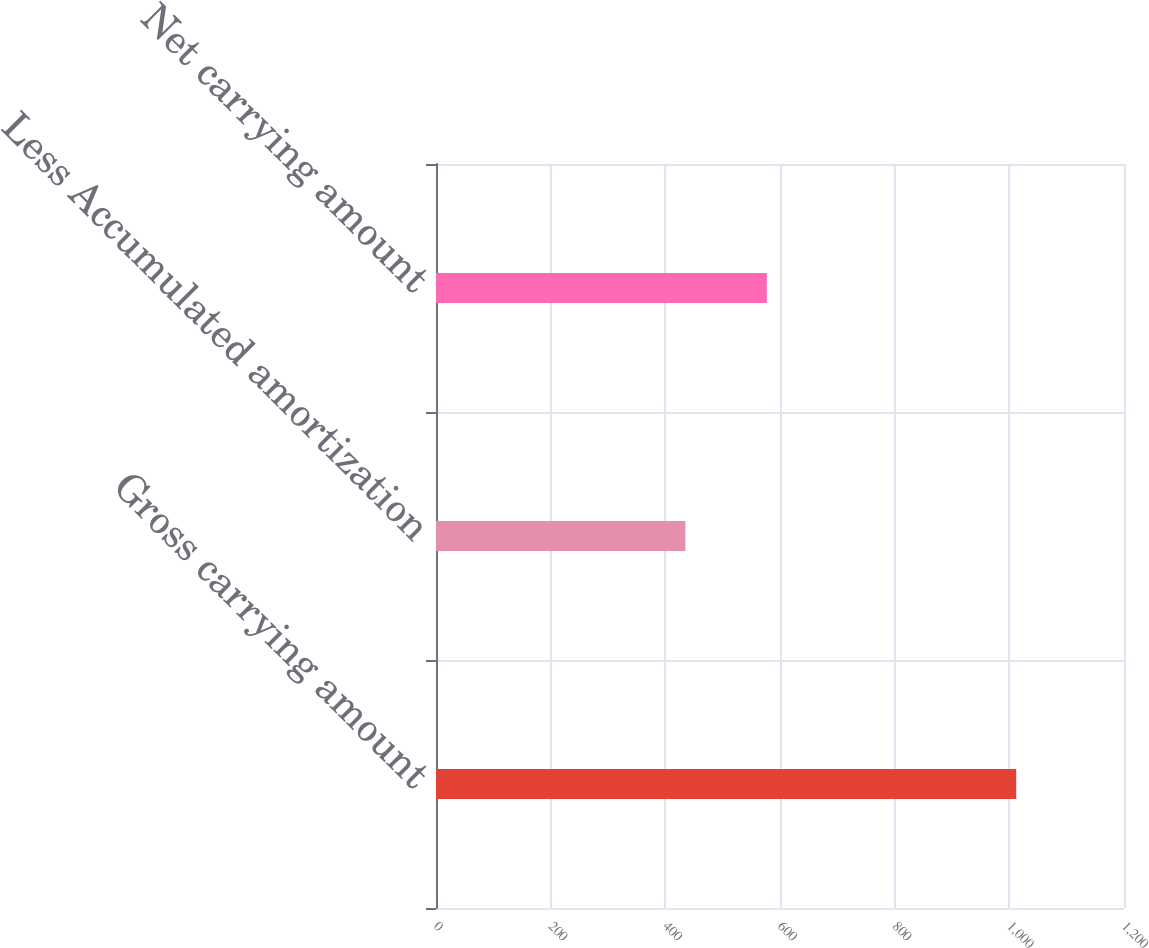Convert chart. <chart><loc_0><loc_0><loc_500><loc_500><bar_chart><fcel>Gross carrying amount<fcel>Less Accumulated amortization<fcel>Net carrying amount<nl><fcel>1012<fcel>435<fcel>577<nl></chart> 